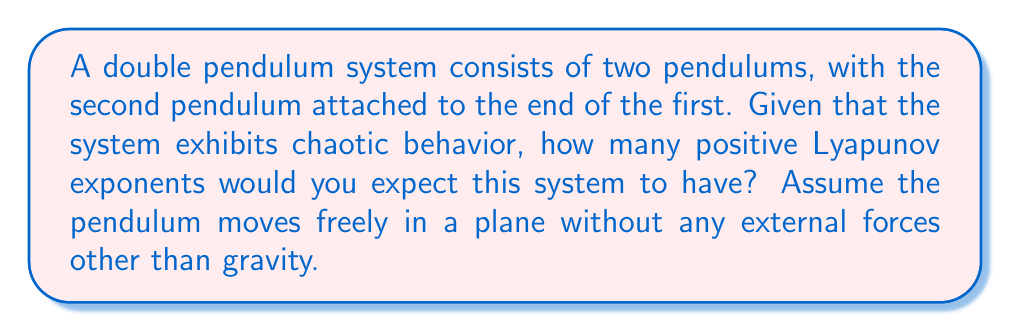Teach me how to tackle this problem. To determine the number of positive Lyapunov exponents for a chaotic double pendulum system, we need to consider the following steps:

1. Degrees of freedom:
   A double pendulum moving in a plane has 2 degrees of freedom, corresponding to the angles of each pendulum arm.

2. Phase space dimensions:
   The phase space of the system includes both position and momentum variables. For each degree of freedom, we have one position variable and one momentum variable. Therefore, the phase space dimension is 4 (2 positions + 2 momenta).

3. Lyapunov exponents:
   In a 4-dimensional phase space, there are 4 Lyapunov exponents in total.

4. Conservation of energy:
   The double pendulum system conserves energy, which implies that the sum of all Lyapunov exponents must be zero.

5. Characteristics of chaotic systems:
   For a system to be chaotic, it must have at least one positive Lyapunov exponent, indicating exponential divergence of nearby trajectories.

6. Number of positive exponents:
   In a conservative system with $n$ degrees of freedom, the number of positive Lyapunov exponents is typically $n-1$ for chaotic behavior.

   For our double pendulum with 2 degrees of freedom, we expect $2-1 = 1$ positive Lyapunov exponent.

7. Exponent pairing:
   In Hamiltonian systems (like the double pendulum), Lyapunov exponents come in pairs with equal magnitude and opposite signs.

Therefore, for a chaotic double pendulum system, we expect:
- 1 positive Lyapunov exponent
- 1 negative Lyapunov exponent (paired with the positive one)
- 2 zero Lyapunov exponents (corresponding to the conservation of energy and the direction of the flow)

This configuration satisfies both the chaotic nature of the system and the conservation of energy principle.
Answer: 1 